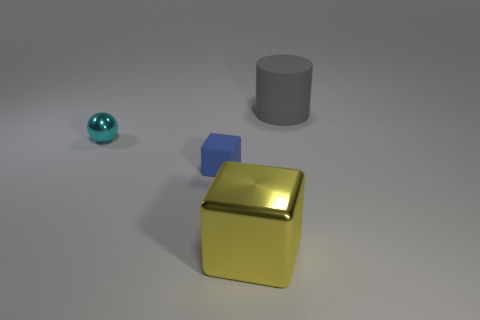Imagine these objects are part of a story; what narrative could they tell? These objects could represent characters in a story about balance and contrast. The small blue ball might be a curious traveler, the medium gray cylinder a wise elder, and the large yellow block a guardian of sorts, each playing a role in maintaining equilibrium in their abstract world. 